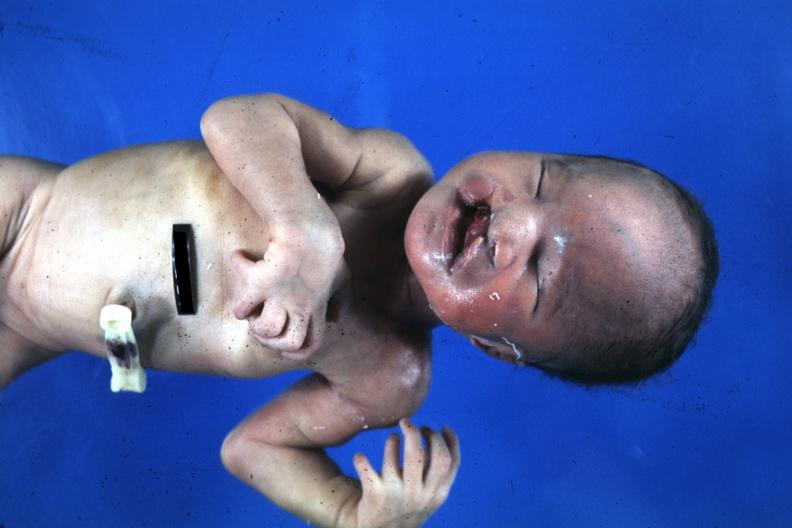s bilateral cleft palate present?
Answer the question using a single word or phrase. Yes 